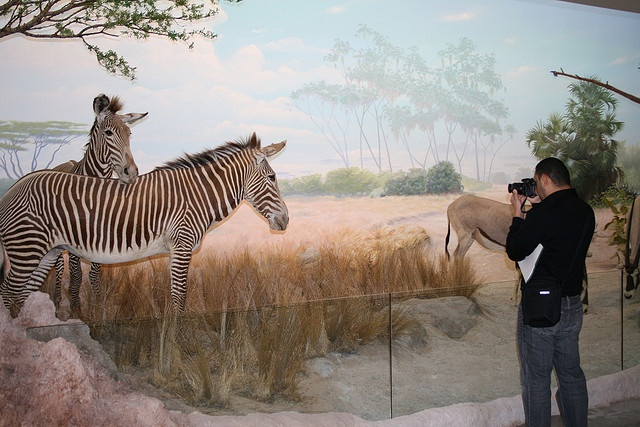Describe the objects in this image and their specific colors. I can see zebra in darkgray, black, maroon, and gray tones, people in darkgray, black, gray, and brown tones, zebra in darkgray, black, gray, and maroon tones, and handbag in darkgray, black, lavender, navy, and violet tones in this image. 